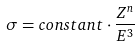Convert formula to latex. <formula><loc_0><loc_0><loc_500><loc_500>\sigma = c o n s t a n t \cdot { \frac { Z ^ { n } } { E ^ { 3 } } }</formula> 